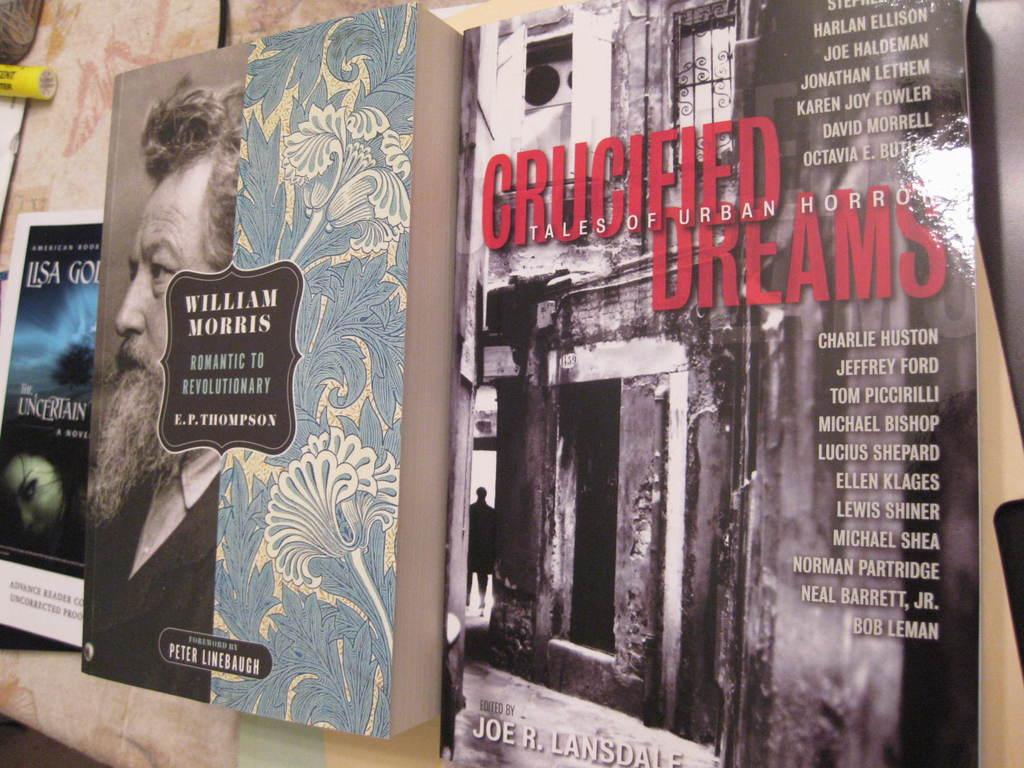Who is one of the authors?
Ensure brevity in your answer.  William morris. 